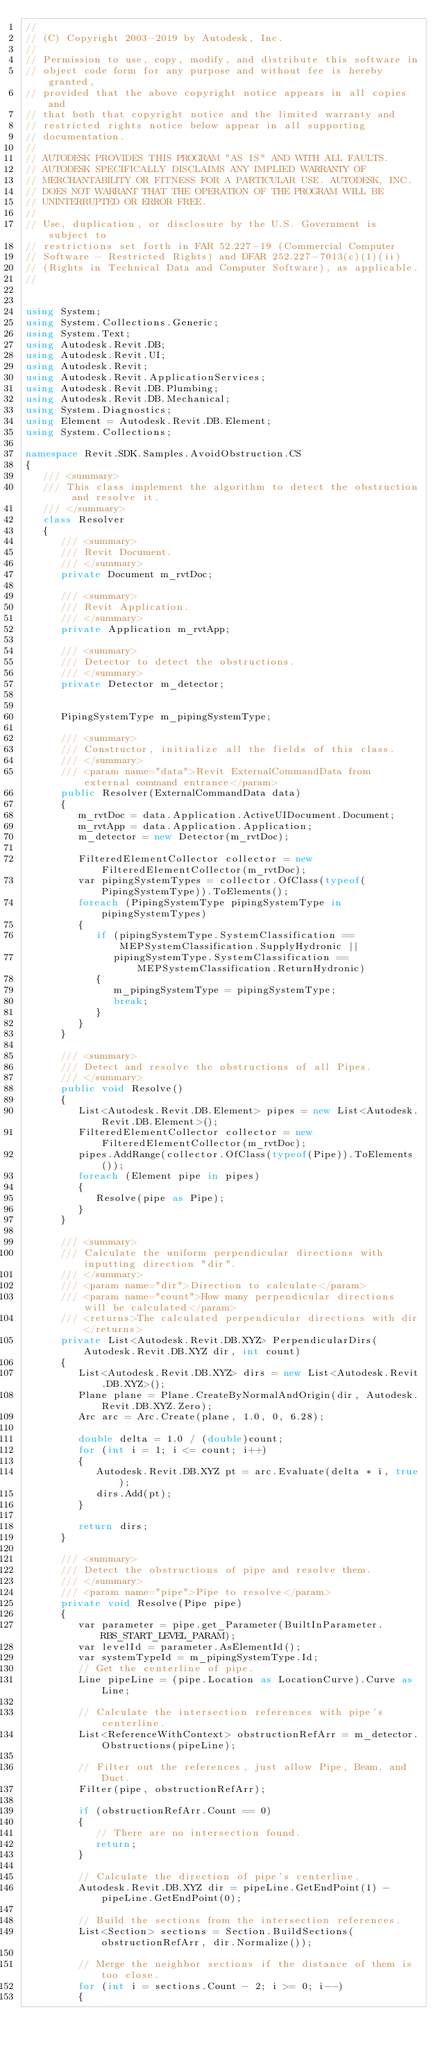Convert code to text. <code><loc_0><loc_0><loc_500><loc_500><_C#_>//
// (C) Copyright 2003-2019 by Autodesk, Inc.
//
// Permission to use, copy, modify, and distribute this software in
// object code form for any purpose and without fee is hereby granted,
// provided that the above copyright notice appears in all copies and
// that both that copyright notice and the limited warranty and
// restricted rights notice below appear in all supporting
// documentation.
//
// AUTODESK PROVIDES THIS PROGRAM "AS IS" AND WITH ALL FAULTS.
// AUTODESK SPECIFICALLY DISCLAIMS ANY IMPLIED WARRANTY OF
// MERCHANTABILITY OR FITNESS FOR A PARTICULAR USE. AUTODESK, INC.
// DOES NOT WARRANT THAT THE OPERATION OF THE PROGRAM WILL BE
// UNINTERRUPTED OR ERROR FREE.
//
// Use, duplication, or disclosure by the U.S. Government is subject to
// restrictions set forth in FAR 52.227-19 (Commercial Computer
// Software - Restricted Rights) and DFAR 252.227-7013(c)(1)(ii)
// (Rights in Technical Data and Computer Software), as applicable.
//


using System;
using System.Collections.Generic;
using System.Text;
using Autodesk.Revit.DB;
using Autodesk.Revit.UI;
using Autodesk.Revit;
using Autodesk.Revit.ApplicationServices;
using Autodesk.Revit.DB.Plumbing;
using Autodesk.Revit.DB.Mechanical;
using System.Diagnostics;
using Element = Autodesk.Revit.DB.Element;
using System.Collections;

namespace Revit.SDK.Samples.AvoidObstruction.CS
{
   /// <summary>
   /// This class implement the algorithm to detect the obstruction and resolve it.
   /// </summary>
   class Resolver
   {
      /// <summary>
      /// Revit Document.
      /// </summary>
      private Document m_rvtDoc;

      /// <summary>
      /// Revit Application.
      /// </summary>
      private Application m_rvtApp;

      /// <summary>
      /// Detector to detect the obstructions.
      /// </summary>
      private Detector m_detector;


      PipingSystemType m_pipingSystemType;

      /// <summary>
      /// Constructor, initialize all the fields of this class.
      /// </summary>
      /// <param name="data">Revit ExternalCommandData from external command entrance</param>
      public Resolver(ExternalCommandData data)
      {
         m_rvtDoc = data.Application.ActiveUIDocument.Document;
         m_rvtApp = data.Application.Application;
         m_detector = new Detector(m_rvtDoc);

         FilteredElementCollector collector = new FilteredElementCollector(m_rvtDoc);
         var pipingSystemTypes = collector.OfClass(typeof(PipingSystemType)).ToElements();
         foreach (PipingSystemType pipingSystemType in pipingSystemTypes)
         {
            if (pipingSystemType.SystemClassification == MEPSystemClassification.SupplyHydronic ||
               pipingSystemType.SystemClassification == MEPSystemClassification.ReturnHydronic)
            {
               m_pipingSystemType = pipingSystemType; 
               break;
            }
         }
      }

      /// <summary>
      /// Detect and resolve the obstructions of all Pipes.
      /// </summary>
      public void Resolve()
      {
         List<Autodesk.Revit.DB.Element> pipes = new List<Autodesk.Revit.DB.Element>();
         FilteredElementCollector collector = new FilteredElementCollector(m_rvtDoc);
         pipes.AddRange(collector.OfClass(typeof(Pipe)).ToElements());
         foreach (Element pipe in pipes)
         {
            Resolve(pipe as Pipe);
         }
      }

      /// <summary>
      /// Calculate the uniform perpendicular directions with inputting direction "dir".
      /// </summary>
      /// <param name="dir">Direction to calculate</param>
      /// <param name="count">How many perpendicular directions will be calculated</param>
      /// <returns>The calculated perpendicular directions with dir</returns>
      private List<Autodesk.Revit.DB.XYZ> PerpendicularDirs(Autodesk.Revit.DB.XYZ dir, int count)
      {
         List<Autodesk.Revit.DB.XYZ> dirs = new List<Autodesk.Revit.DB.XYZ>();
         Plane plane = Plane.CreateByNormalAndOrigin(dir, Autodesk.Revit.DB.XYZ.Zero);
         Arc arc = Arc.Create(plane, 1.0, 0, 6.28);

         double delta = 1.0 / (double)count;
         for (int i = 1; i <= count; i++)
         {
            Autodesk.Revit.DB.XYZ pt = arc.Evaluate(delta * i, true);
            dirs.Add(pt);
         }

         return dirs;
      }

      /// <summary>
      /// Detect the obstructions of pipe and resolve them.
      /// </summary>
      /// <param name="pipe">Pipe to resolve</param>
      private void Resolve(Pipe pipe)
      {
         var parameter = pipe.get_Parameter(BuiltInParameter.RBS_START_LEVEL_PARAM);
         var levelId = parameter.AsElementId();
         var systemTypeId = m_pipingSystemType.Id;
         // Get the centerline of pipe.
         Line pipeLine = (pipe.Location as LocationCurve).Curve as Line;

         // Calculate the intersection references with pipe's centerline.
         List<ReferenceWithContext> obstructionRefArr = m_detector.Obstructions(pipeLine);

         // Filter out the references, just allow Pipe, Beam, and Duct.
         Filter(pipe, obstructionRefArr);

         if (obstructionRefArr.Count == 0)
         {
            // There are no intersection found.
            return;
         }

         // Calculate the direction of pipe's centerline.
         Autodesk.Revit.DB.XYZ dir = pipeLine.GetEndPoint(1) - pipeLine.GetEndPoint(0);

         // Build the sections from the intersection references.
         List<Section> sections = Section.BuildSections(obstructionRefArr, dir.Normalize());

         // Merge the neighbor sections if the distance of them is too close.
         for (int i = sections.Count - 2; i >= 0; i--)
         {</code> 